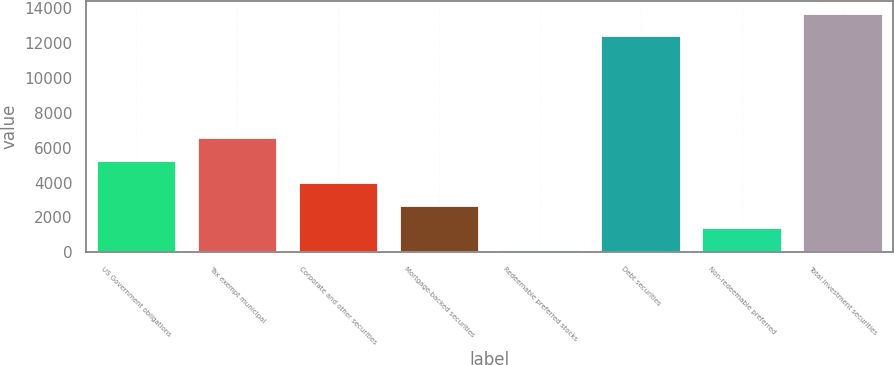Convert chart. <chart><loc_0><loc_0><loc_500><loc_500><bar_chart><fcel>US Government obligations<fcel>Tax exempt municipal<fcel>Corporate and other securities<fcel>Mortgage-backed securities<fcel>Redeemable preferred stocks<fcel>Debt securities<fcel>Non-redeemable preferred<fcel>Total investment securities<nl><fcel>5314.8<fcel>6601<fcel>4028.6<fcel>2742.4<fcel>170<fcel>12463<fcel>1456.2<fcel>13749.2<nl></chart> 